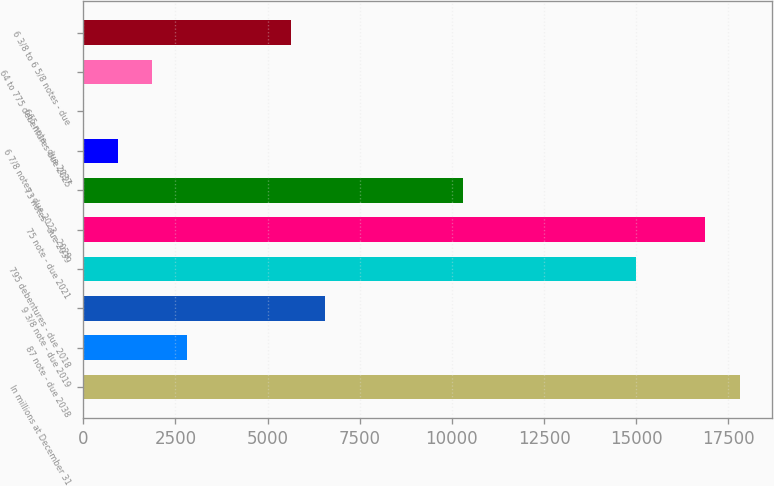<chart> <loc_0><loc_0><loc_500><loc_500><bar_chart><fcel>In millions at December 31<fcel>87 note - due 2038<fcel>9 3/8 note - due 2019<fcel>795 debentures - due 2018<fcel>75 note - due 2021<fcel>73 notes - due 2039<fcel>6 7/8 notes - due 2023 - 2029<fcel>665 note - due 2037<fcel>64 to 775 debentures due 2025<fcel>6 3/8 to 6 5/8 notes - due<nl><fcel>17805.1<fcel>2814.7<fcel>6562.3<fcel>14994.4<fcel>16868.2<fcel>10309.9<fcel>940.9<fcel>4<fcel>1877.8<fcel>5625.4<nl></chart> 